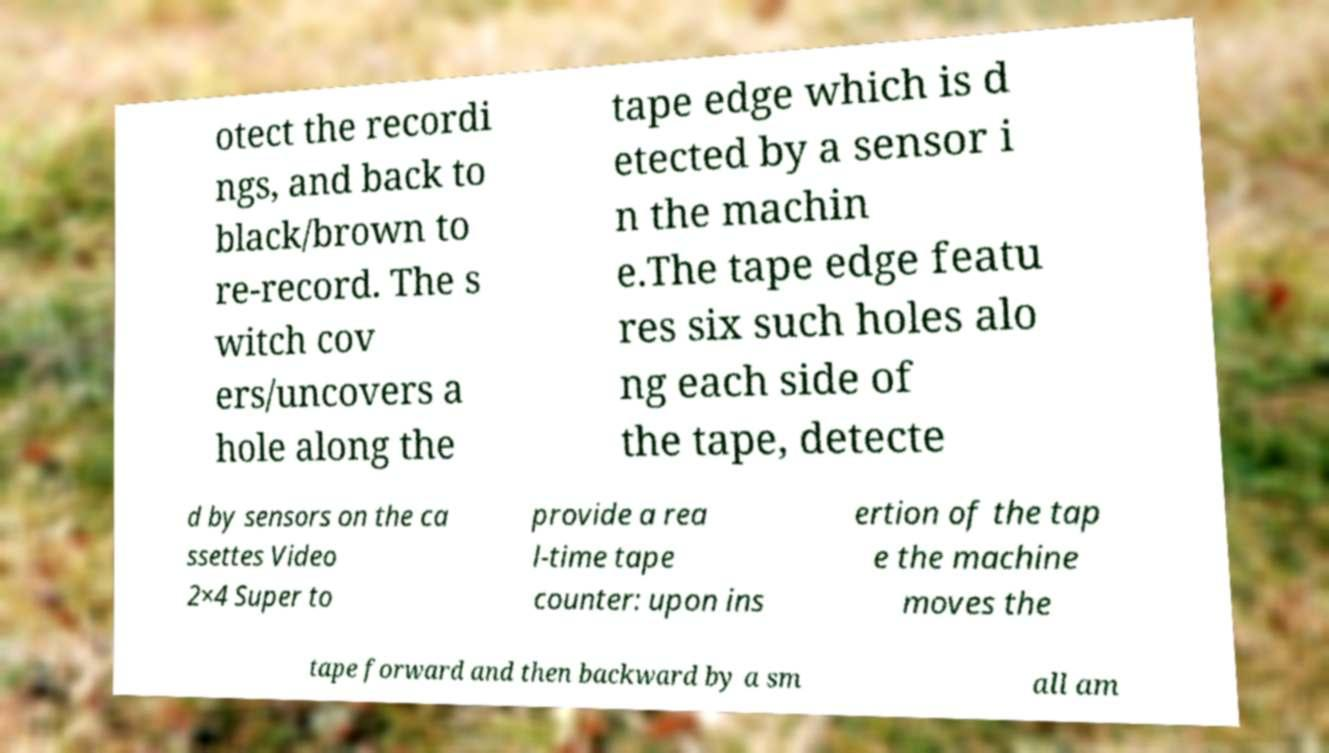There's text embedded in this image that I need extracted. Can you transcribe it verbatim? otect the recordi ngs, and back to black/brown to re-record. The s witch cov ers/uncovers a hole along the tape edge which is d etected by a sensor i n the machin e.The tape edge featu res six such holes alo ng each side of the tape, detecte d by sensors on the ca ssettes Video 2×4 Super to provide a rea l-time tape counter: upon ins ertion of the tap e the machine moves the tape forward and then backward by a sm all am 